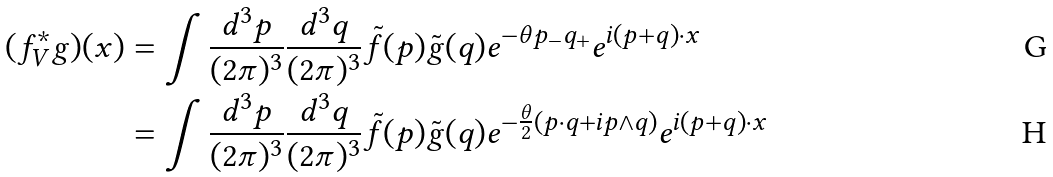Convert formula to latex. <formula><loc_0><loc_0><loc_500><loc_500>( f ^ { * } _ { V } g ) ( x ) & = \int \frac { d ^ { 3 } p } { ( 2 \pi ) ^ { 3 } } \frac { d ^ { 3 } q } { ( 2 \pi ) ^ { 3 } } \tilde { f } ( p ) \tilde { g } ( q ) e ^ { - \theta p _ { - } q _ { + } } e ^ { i ( p + q ) \cdot x } \\ & = \int \frac { d ^ { 3 } p } { ( 2 \pi ) ^ { 3 } } \frac { d ^ { 3 } q } { ( 2 \pi ) ^ { 3 } } \tilde { f } ( p ) \tilde { g } ( q ) e ^ { - \frac { \theta } { 2 } ( p \cdot q + i p \wedge q ) } e ^ { i ( p + q ) \cdot x }</formula> 